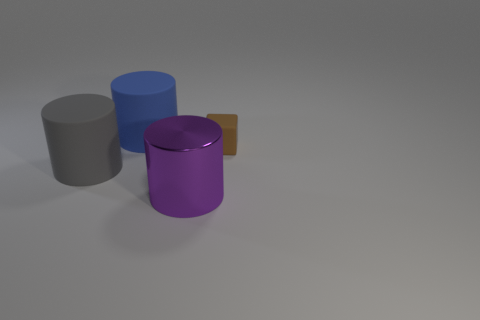Is there anything else that has the same material as the big gray object?
Your answer should be very brief. Yes. Is the cylinder behind the large gray rubber thing made of the same material as the big gray cylinder?
Provide a succinct answer. Yes. There is a thing on the right side of the large cylinder that is right of the blue rubber object that is behind the small brown object; what is its material?
Ensure brevity in your answer.  Rubber. What number of other things are the same shape as the tiny object?
Offer a terse response. 0. What is the color of the thing that is right of the purple object?
Give a very brief answer. Brown. How many rubber cylinders are to the left of the rubber thing that is on the right side of the large cylinder in front of the gray cylinder?
Your answer should be very brief. 2. There is a rubber cylinder that is behind the tiny thing; what number of rubber objects are behind it?
Provide a short and direct response. 0. What number of big matte cylinders are in front of the brown rubber thing?
Provide a succinct answer. 1. How many other objects are there of the same size as the brown cube?
Provide a short and direct response. 0. There is a gray rubber thing that is the same shape as the big purple metallic object; what size is it?
Provide a succinct answer. Large. 